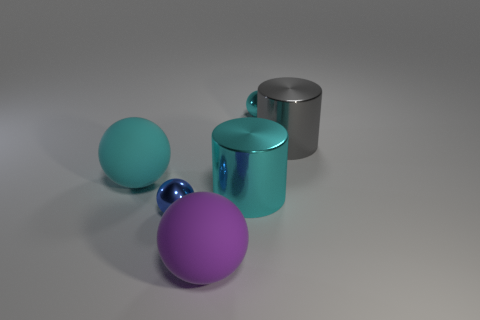Add 1 small purple metal cylinders. How many objects exist? 7 Subtract all cylinders. How many objects are left? 4 Subtract all tiny blue rubber blocks. Subtract all gray objects. How many objects are left? 5 Add 4 gray metallic objects. How many gray metallic objects are left? 5 Add 2 small purple spheres. How many small purple spheres exist? 2 Subtract 0 brown spheres. How many objects are left? 6 